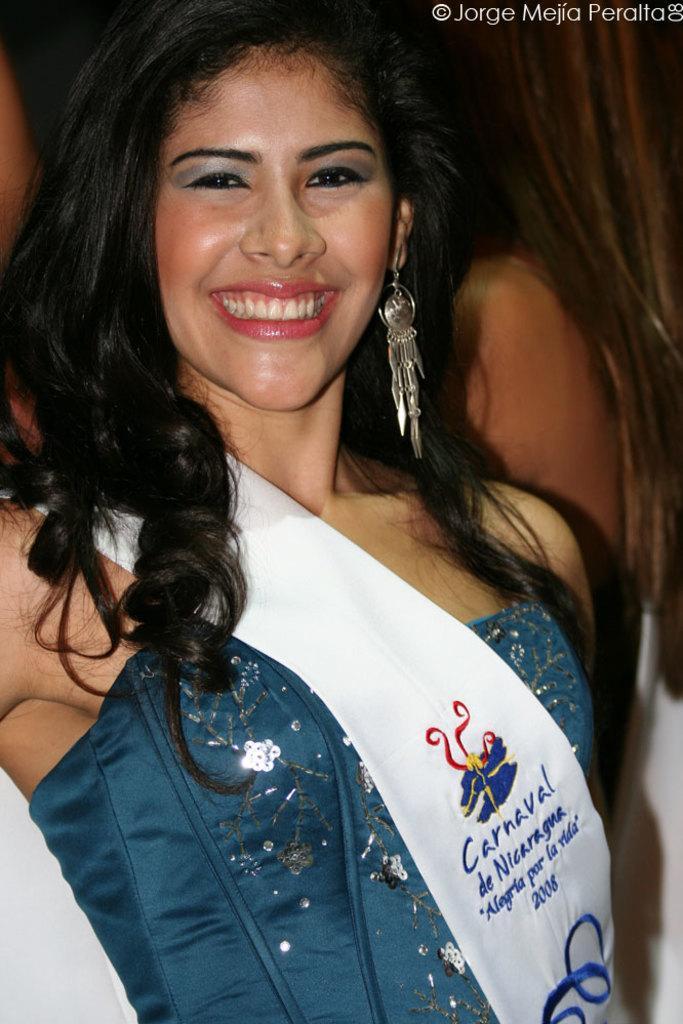How would you summarize this image in a sentence or two? In this image I can see women. She is wearing blue color dress and a white cloth. 